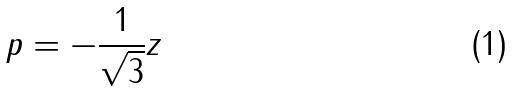<formula> <loc_0><loc_0><loc_500><loc_500>p = - \frac { 1 } { \sqrt { 3 } } z</formula> 